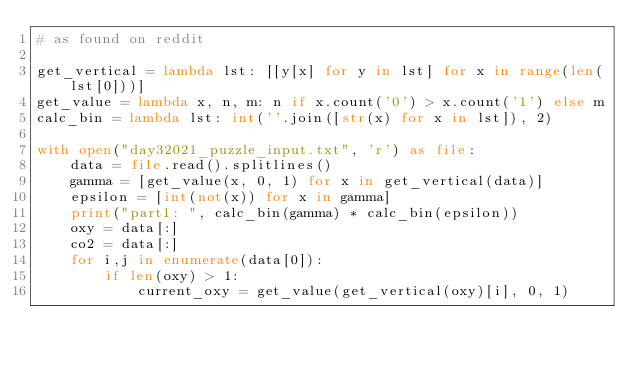<code> <loc_0><loc_0><loc_500><loc_500><_Python_># as found on reddit

get_vertical = lambda lst: [[y[x] for y in lst] for x in range(len(lst[0]))]
get_value = lambda x, n, m: n if x.count('0') > x.count('1') else m
calc_bin = lambda lst: int(''.join([str(x) for x in lst]), 2)

with open("day32021_puzzle_input.txt", 'r') as file: 
    data = file.read().splitlines()    
    gamma = [get_value(x, 0, 1) for x in get_vertical(data)]
    epsilon = [int(not(x)) for x in gamma]
    print("part1: ", calc_bin(gamma) * calc_bin(epsilon)) 
    oxy = data[:]
    co2 = data[:]
    for i,j in enumerate(data[0]):
        if len(oxy) > 1:
            current_oxy = get_value(get_vertical(oxy)[i], 0, 1)</code> 